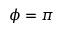Convert formula to latex. <formula><loc_0><loc_0><loc_500><loc_500>\phi = \pi</formula> 